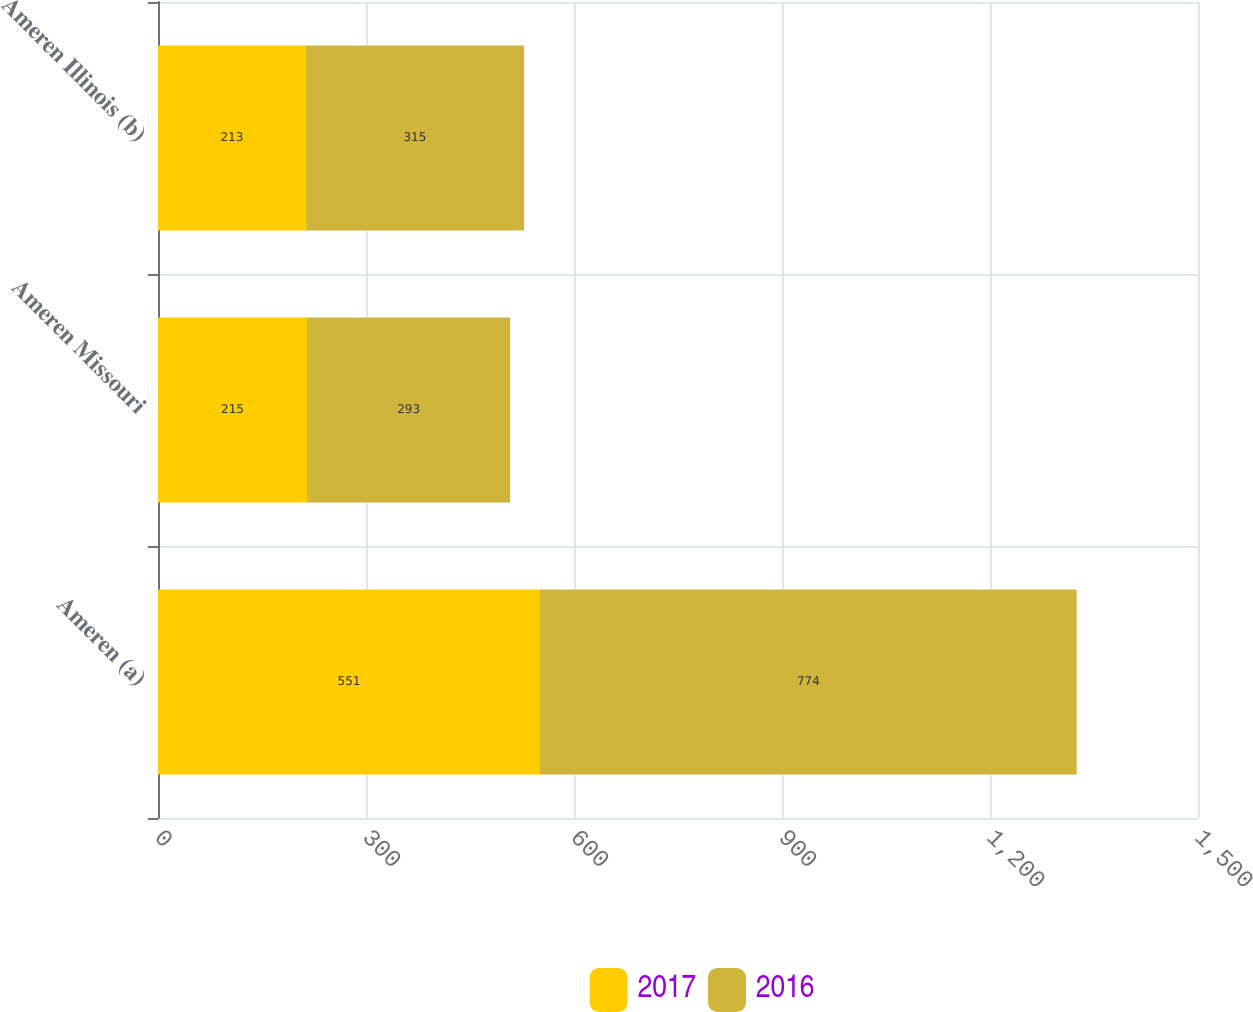<chart> <loc_0><loc_0><loc_500><loc_500><stacked_bar_chart><ecel><fcel>Ameren (a)<fcel>Ameren Missouri<fcel>Ameren Illinois (b)<nl><fcel>2017<fcel>551<fcel>215<fcel>213<nl><fcel>2016<fcel>774<fcel>293<fcel>315<nl></chart> 